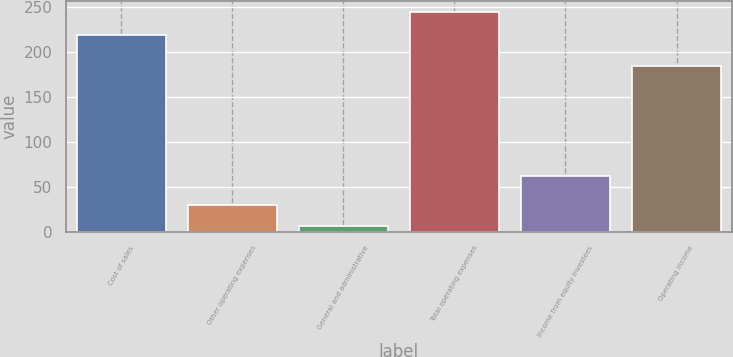Convert chart. <chart><loc_0><loc_0><loc_500><loc_500><bar_chart><fcel>Cost of sales<fcel>Other operating expenses<fcel>General and administrative<fcel>Total operating expenses<fcel>Income from equity investees<fcel>Operating income<nl><fcel>218.3<fcel>30.09<fcel>6.3<fcel>244.2<fcel>61.5<fcel>183.6<nl></chart> 